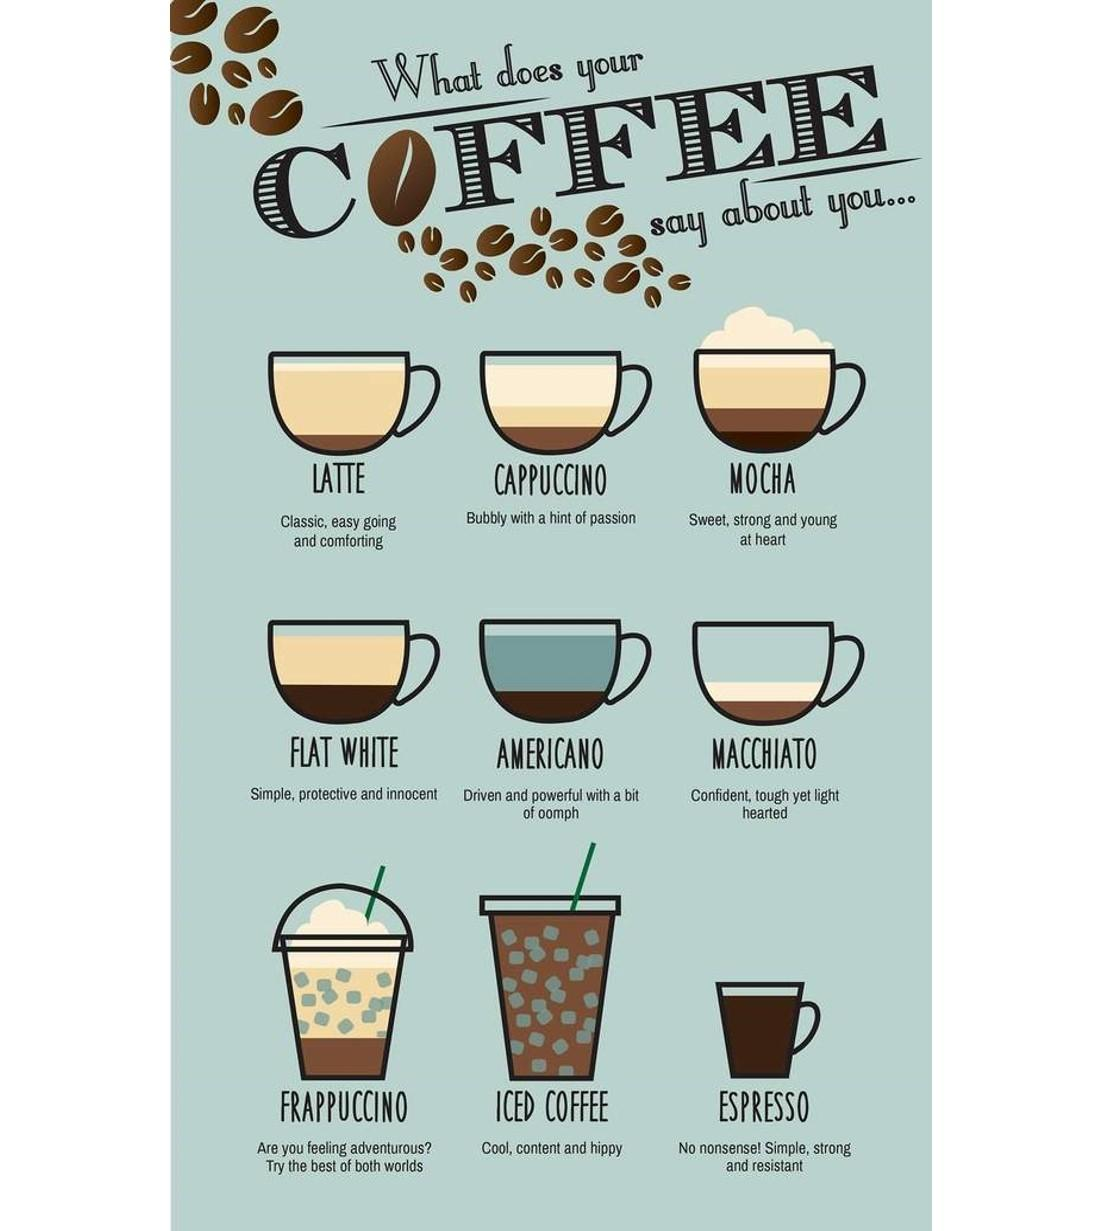Highlight a few significant elements in this photo. There are a total of nine types of coffee mentioned. 